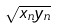<formula> <loc_0><loc_0><loc_500><loc_500>\sqrt { x _ { n } y _ { n } }</formula> 